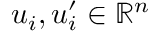Convert formula to latex. <formula><loc_0><loc_0><loc_500><loc_500>u _ { i } , u _ { i } ^ { \prime } \in \mathbb { R } ^ { n }</formula> 